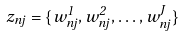Convert formula to latex. <formula><loc_0><loc_0><loc_500><loc_500>z _ { n j } = \{ w _ { n j } ^ { 1 } , w _ { n j } ^ { 2 } , \dots , w _ { n j } ^ { J } \}</formula> 